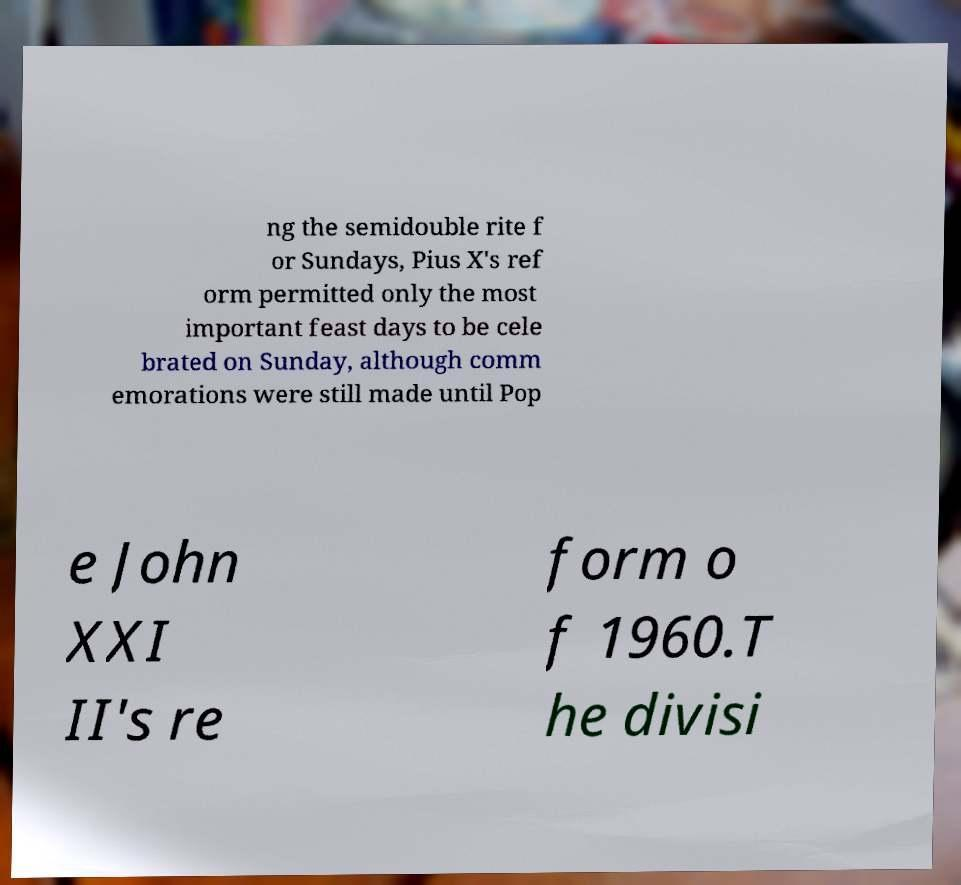Could you extract and type out the text from this image? ng the semidouble rite f or Sundays, Pius X's ref orm permitted only the most important feast days to be cele brated on Sunday, although comm emorations were still made until Pop e John XXI II's re form o f 1960.T he divisi 